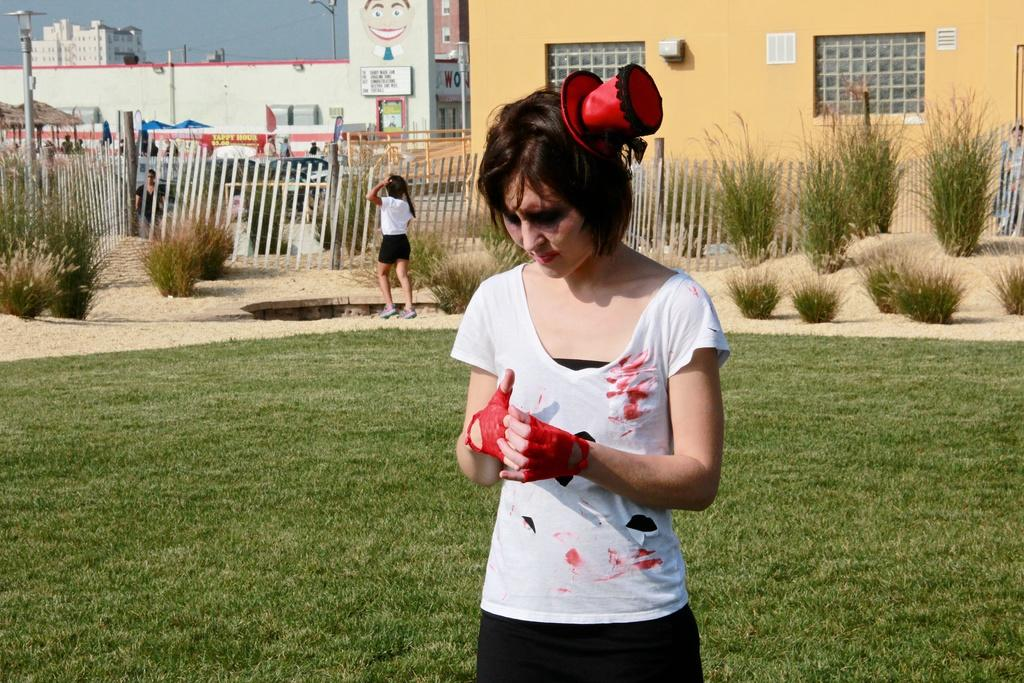How many people are in the image? There are people in the image, but the exact number is not specified. What type of terrain is visible at the bottom of the image? There is: There is grass at the bottom of the image. What other natural elements can be seen in the image? There are plants in the image. What type of man-made structures are present in the image? There are buildings in the image. What are the poles used for in the image? The purpose of the poles is not specified in the facts. What is visible at the top of the image? The sky is visible at the top of the image. What type of barrier is present in the image? There is a fence in the image. How many ants can be seen carrying leaves in the image? There are no ants or leaves visible in the image. What type of flight is taking place in the image? There is no flight or any indication of flying objects in the image. 